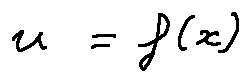<formula> <loc_0><loc_0><loc_500><loc_500>u = f ( x )</formula> 